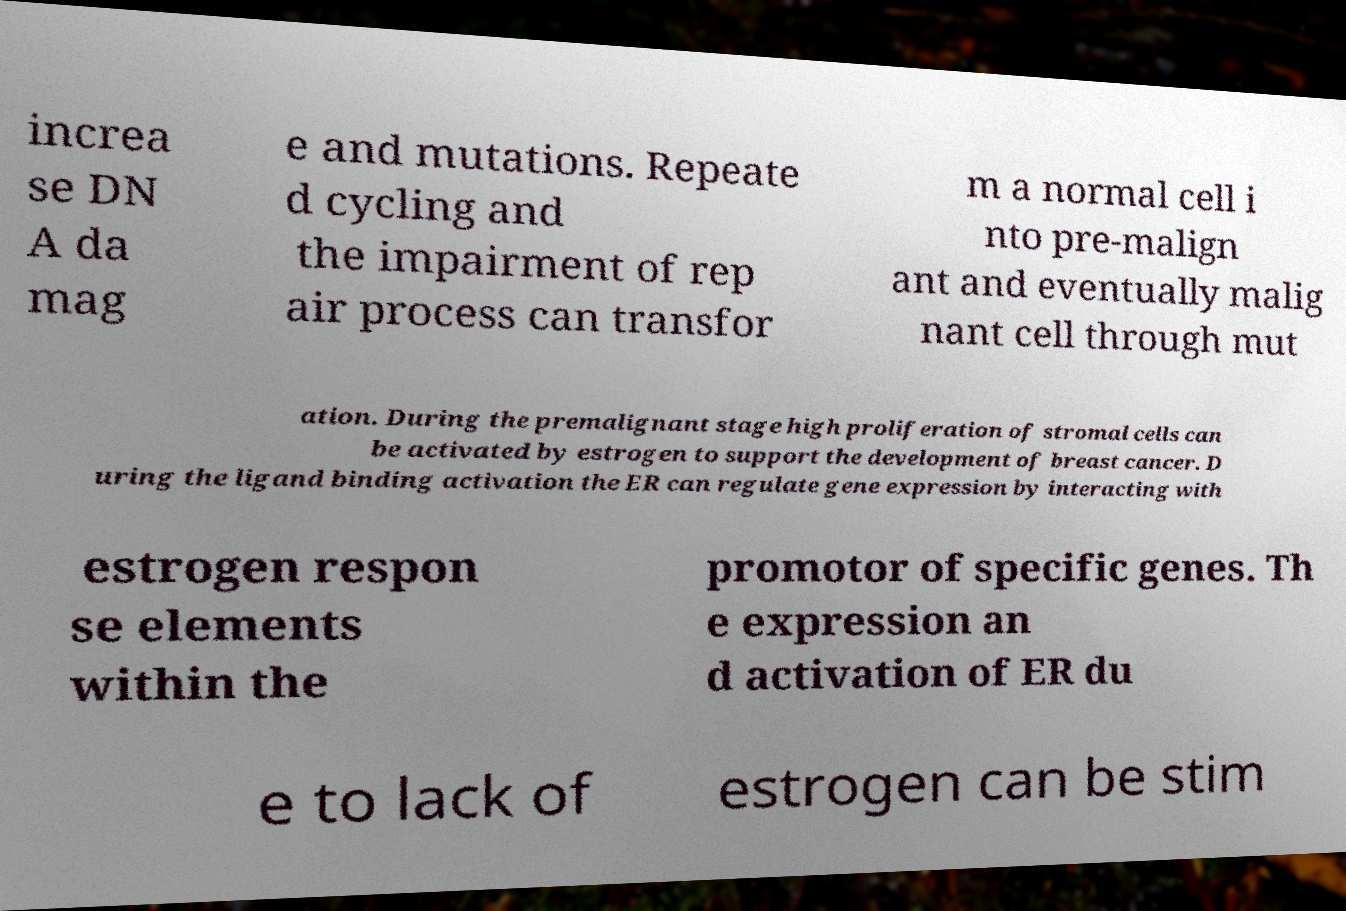What messages or text are displayed in this image? I need them in a readable, typed format. increa se DN A da mag e and mutations. Repeate d cycling and the impairment of rep air process can transfor m a normal cell i nto pre-malign ant and eventually malig nant cell through mut ation. During the premalignant stage high proliferation of stromal cells can be activated by estrogen to support the development of breast cancer. D uring the ligand binding activation the ER can regulate gene expression by interacting with estrogen respon se elements within the promotor of specific genes. Th e expression an d activation of ER du e to lack of estrogen can be stim 